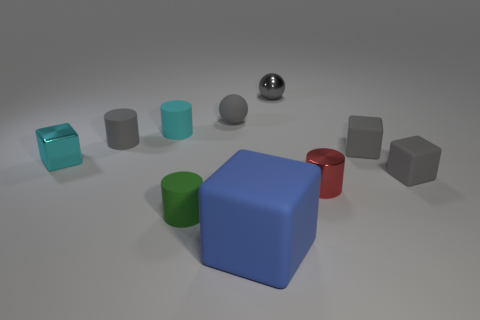Subtract all cyan blocks. How many blocks are left? 3 Subtract all cylinders. How many objects are left? 6 Subtract all cyan cylinders. How many cylinders are left? 3 Subtract 0 green balls. How many objects are left? 10 Subtract 2 cubes. How many cubes are left? 2 Subtract all brown balls. Subtract all red blocks. How many balls are left? 2 Subtract all red balls. How many brown cubes are left? 0 Subtract all shiny things. Subtract all small red metal cylinders. How many objects are left? 6 Add 1 tiny cyan metal cubes. How many tiny cyan metal cubes are left? 2 Add 1 shiny objects. How many shiny objects exist? 4 